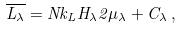<formula> <loc_0><loc_0><loc_500><loc_500>\overline { L _ { \lambda } } = N k _ { L } H _ { \lambda } 2 \mu _ { \lambda } + C _ { \lambda } \, ,</formula> 